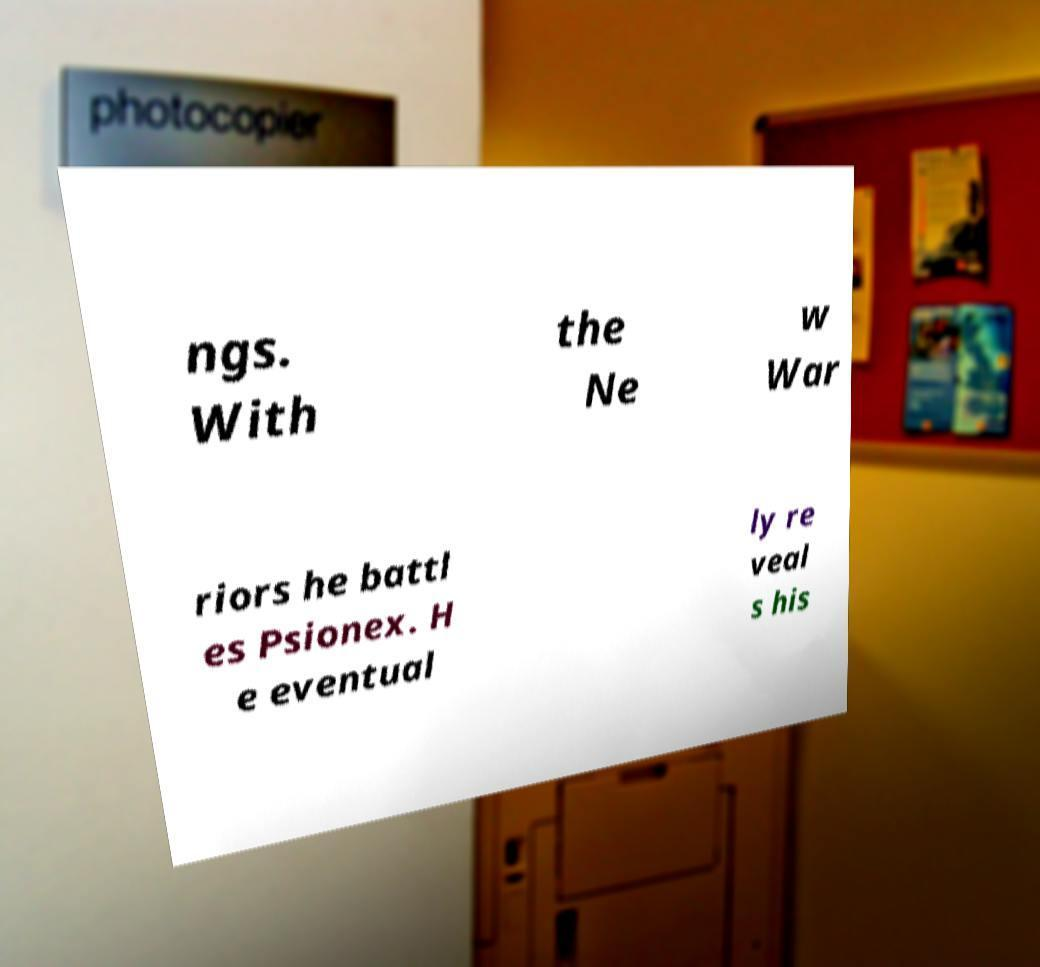Can you read and provide the text displayed in the image?This photo seems to have some interesting text. Can you extract and type it out for me? ngs. With the Ne w War riors he battl es Psionex. H e eventual ly re veal s his 